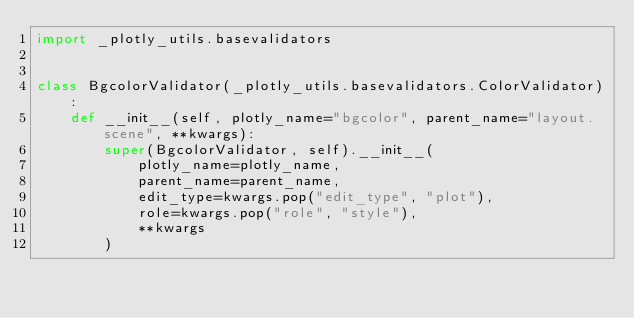<code> <loc_0><loc_0><loc_500><loc_500><_Python_>import _plotly_utils.basevalidators


class BgcolorValidator(_plotly_utils.basevalidators.ColorValidator):
    def __init__(self, plotly_name="bgcolor", parent_name="layout.scene", **kwargs):
        super(BgcolorValidator, self).__init__(
            plotly_name=plotly_name,
            parent_name=parent_name,
            edit_type=kwargs.pop("edit_type", "plot"),
            role=kwargs.pop("role", "style"),
            **kwargs
        )
</code> 